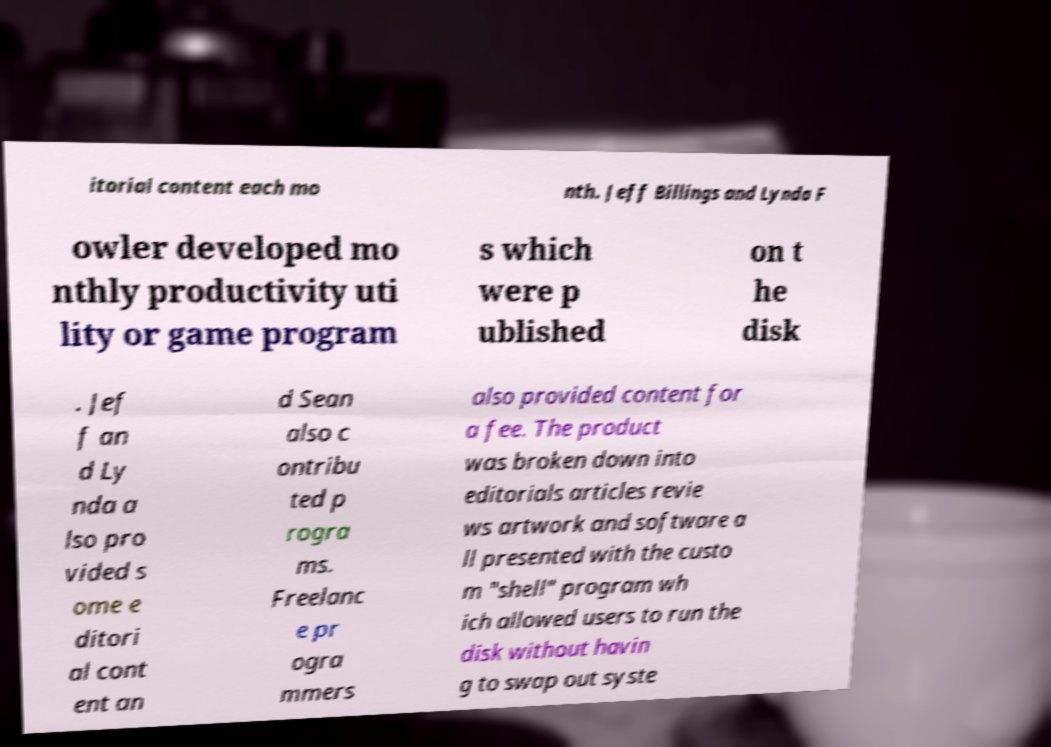There's text embedded in this image that I need extracted. Can you transcribe it verbatim? itorial content each mo nth. Jeff Billings and Lynda F owler developed mo nthly productivity uti lity or game program s which were p ublished on t he disk . Jef f an d Ly nda a lso pro vided s ome e ditori al cont ent an d Sean also c ontribu ted p rogra ms. Freelanc e pr ogra mmers also provided content for a fee. The product was broken down into editorials articles revie ws artwork and software a ll presented with the custo m "shell" program wh ich allowed users to run the disk without havin g to swap out syste 